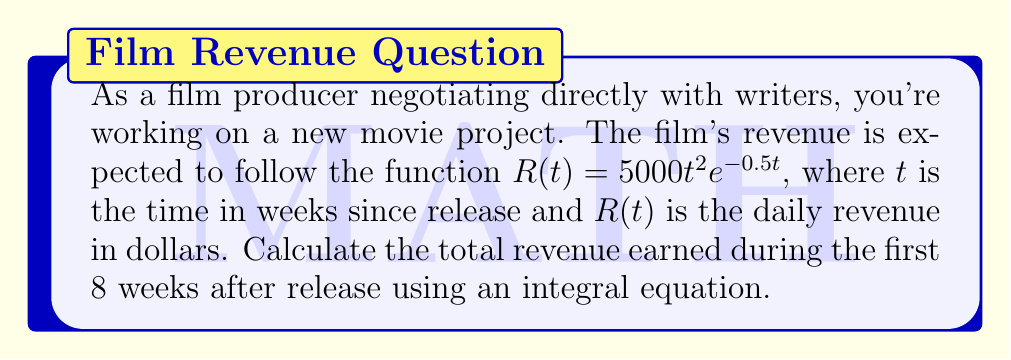What is the answer to this math problem? To solve this problem, we need to integrate the revenue function over the given time period. Here's the step-by-step solution:

1) The total revenue is the integral of the daily revenue function from $t=0$ to $t=8$ weeks:

   $$\text{Total Revenue} = \int_0^8 R(t) dt = \int_0^8 5000t^2e^{-0.5t} dt$$

2) Let's solve this integral using integration by parts twice. Let $u = t^2$ and $dv = e^{-0.5t}dt$.

3) First integration by parts:
   $$\int t^2e^{-0.5t} dt = -2t^2e^{-0.5t} - \int (-2t)(-0.5e^{-0.5t}) dt$$
   $$= -2t^2e^{-0.5t} - 2t\int e^{-0.5t} dt$$

4) Second integration by parts:
   $$= -2t^2e^{-0.5t} - 2t(-2e^{-0.5t}) - 2\int (-2e^{-0.5t}) dt$$
   $$= -2t^2e^{-0.5t} + 4te^{-0.5t} - 8e^{-0.5t} + C$$

5) Now, we apply the limits:
   $$\text{Total Revenue} = 5000 \left[-2t^2e^{-0.5t} + 4te^{-0.5t} - 8e^{-0.5t}\right]_0^8$$

6) Evaluating at $t=8$ and $t=0$:
   $$= 5000 \left[(-2(64)e^{-4} + 4(8)e^{-4} - 8e^{-4}) - (-8)\right]$$
   $$= 5000 \left[-128e^{-4} + 32e^{-4} - 8e^{-4} + 8\right]$$
   $$= 5000 \left[-104e^{-4} + 8\right]$$

7) Calculating the final result:
   $$= 5000 \left[-104(0.0183) + 8\right] = 5000 [-1.9032 + 8] = 30,484$$

The total revenue is approximately $30,484.
Answer: $30,484 